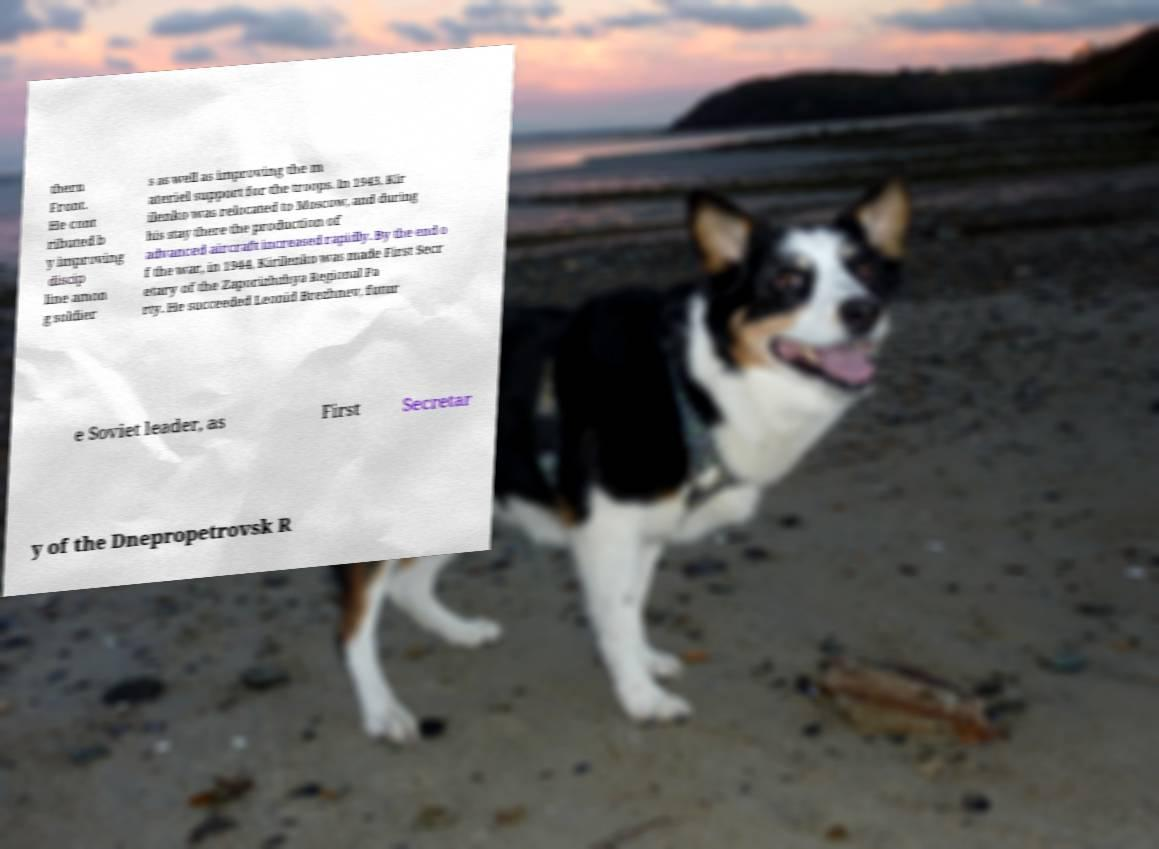Could you extract and type out the text from this image? thern Front. He cont ributed b y improving discip line amon g soldier s as well as improving the m ateriel support for the troops. In 1943, Kir ilenko was relocated to Moscow, and during his stay there the production of advanced aircraft increased rapidly. By the end o f the war, in 1944, Kirilenko was made First Secr etary of the Zaporizhzhya Regional Pa rty. He succeeded Leonid Brezhnev, futur e Soviet leader, as First Secretar y of the Dnepropetrovsk R 